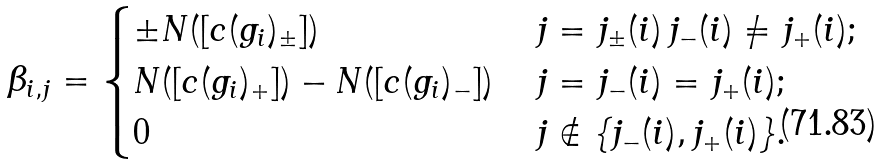<formula> <loc_0><loc_0><loc_500><loc_500>\beta _ { i , j } = \begin{cases} \pm N ( [ c ( g _ { i } ) _ { \pm } ] ) & \, j = j _ { \pm } ( i ) \, j _ { - } ( i ) \not = j _ { + } ( i ) ; \\ N ( [ c ( g _ { i } ) _ { + } ] ) - N ( [ c ( g _ { i } ) _ { - } ] ) & \, j = j _ { - } ( i ) = j _ { + } ( i ) ; \\ 0 & \, j \notin \{ j _ { - } ( i ) , j _ { + } ( i ) \} . \end{cases}</formula> 